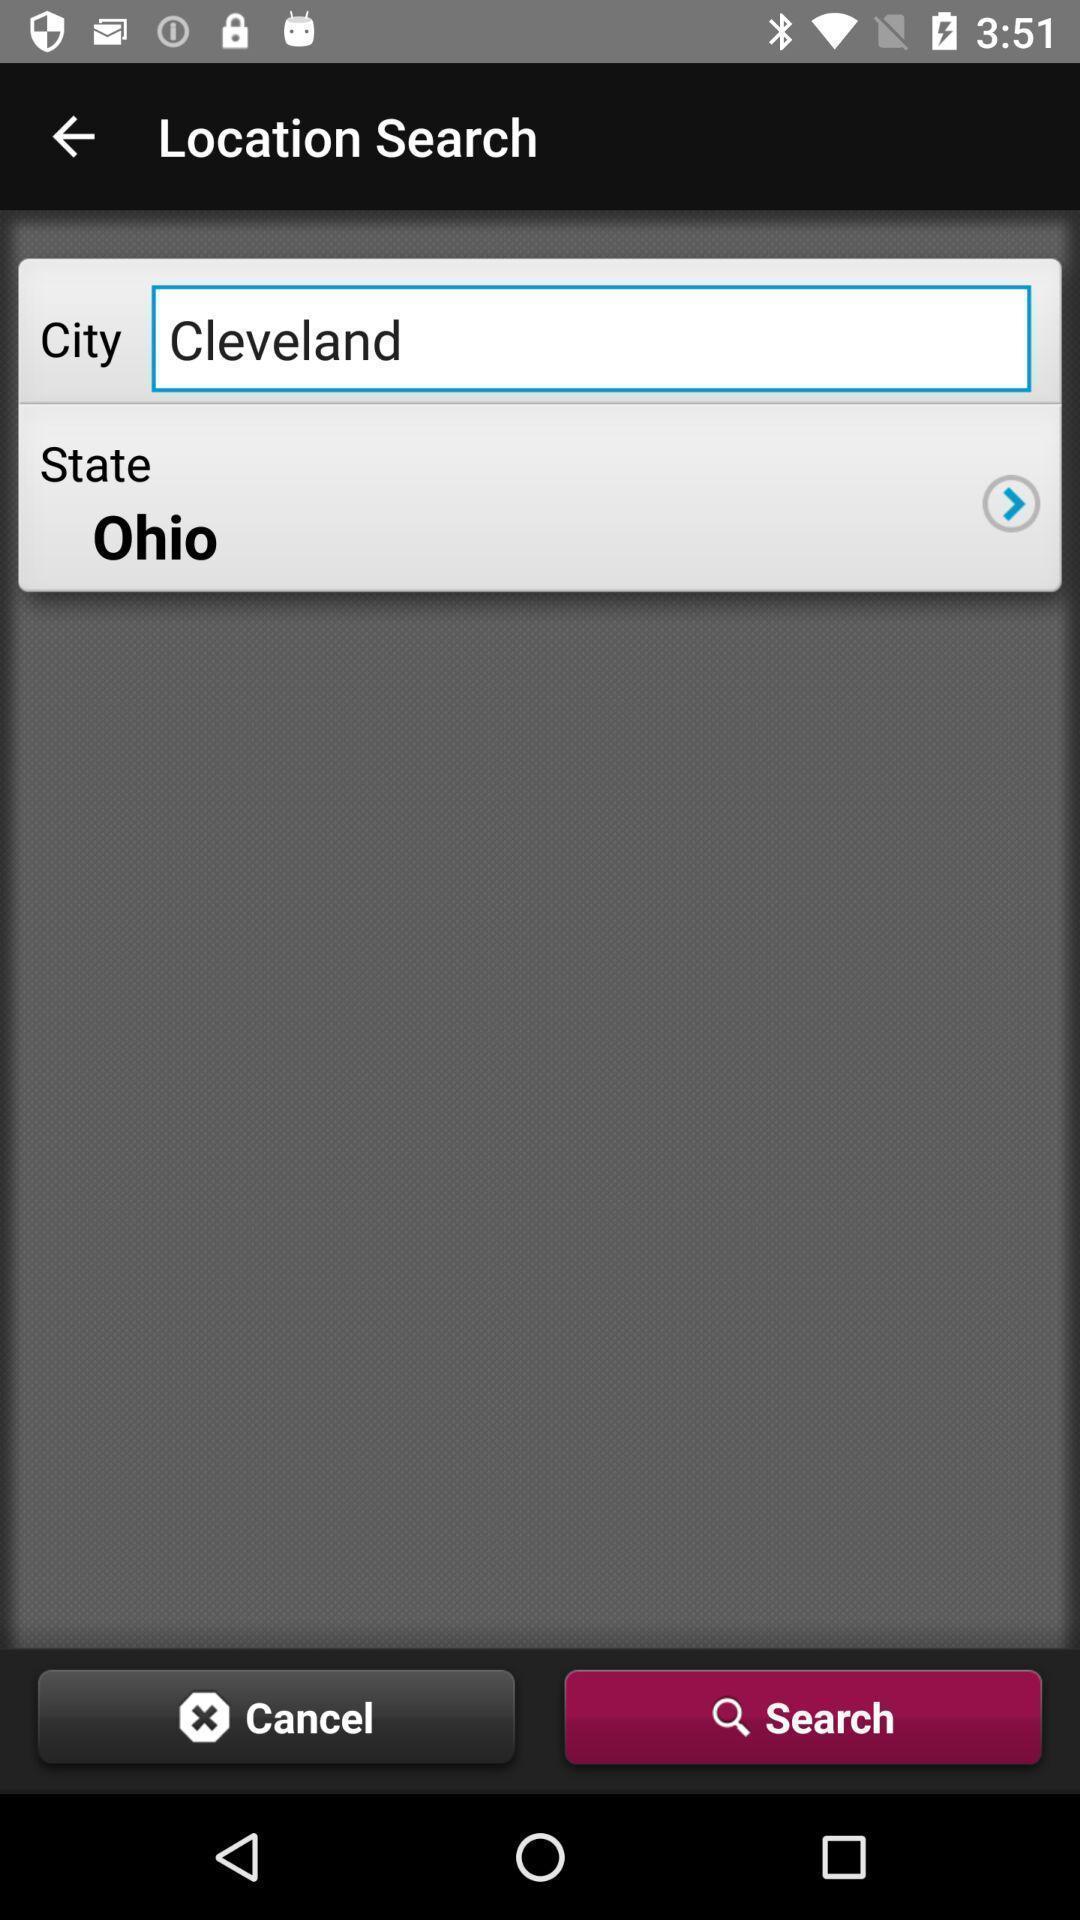Describe the visual elements of this screenshot. Search bar to find locations. 